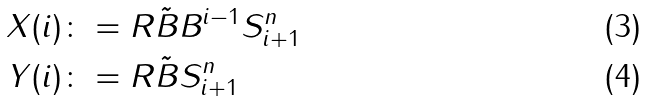Convert formula to latex. <formula><loc_0><loc_0><loc_500><loc_500>X ( i ) & \colon = R \tilde { B } B ^ { i - 1 } S _ { i + 1 } ^ { n } \\ Y ( i ) & \colon = R \tilde { B } S _ { i + 1 } ^ { n }</formula> 